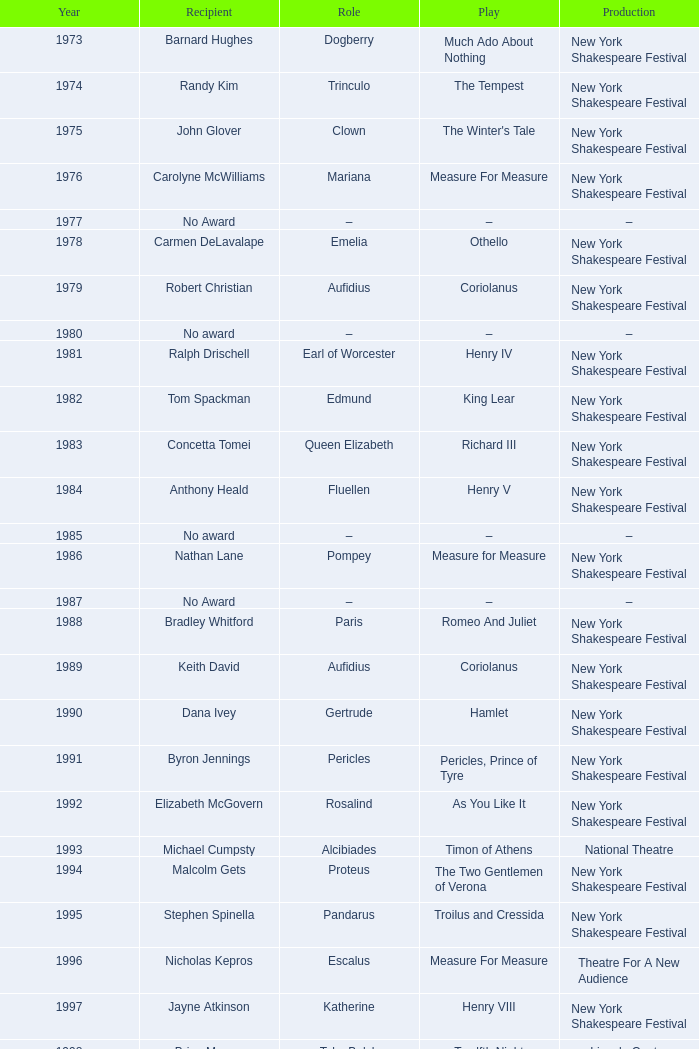Name the recipient of much ado about nothing for 1973 Barnard Hughes. 